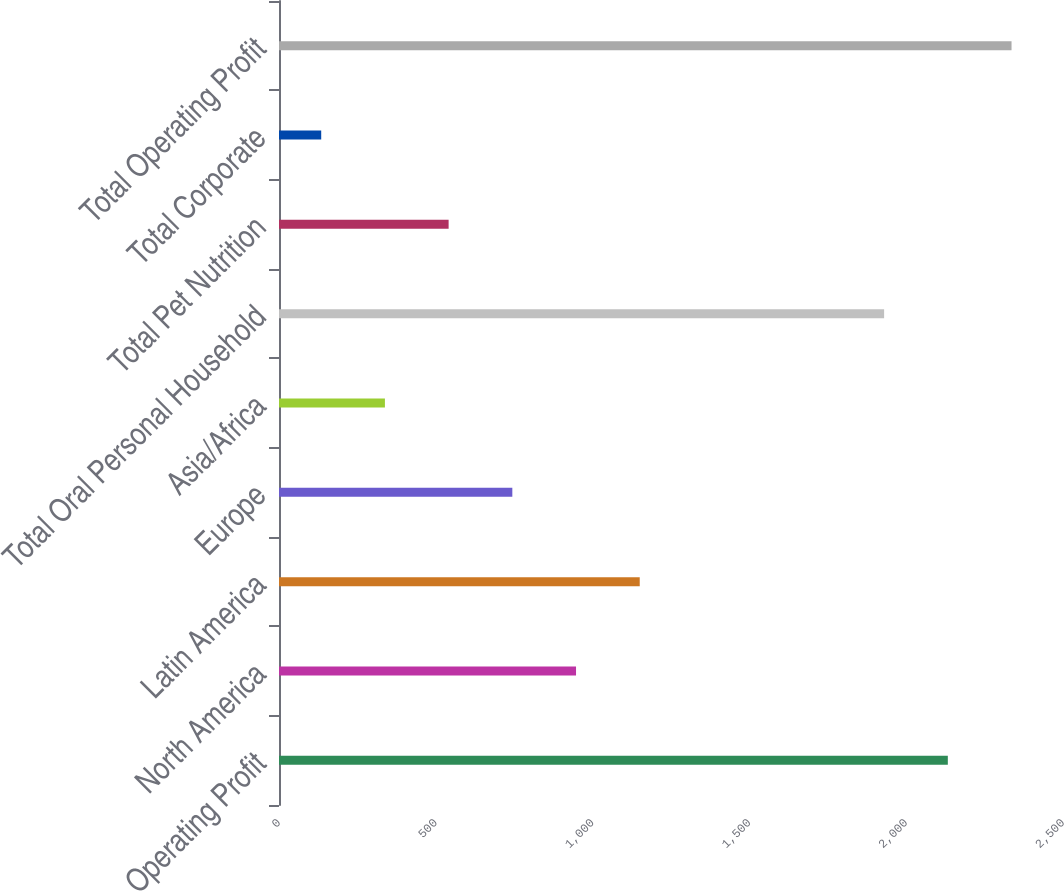Convert chart. <chart><loc_0><loc_0><loc_500><loc_500><bar_chart><fcel>Operating Profit<fcel>North America<fcel>Latin America<fcel>Europe<fcel>Asia/Africa<fcel>Total Oral Personal Household<fcel>Total Pet Nutrition<fcel>Total Corporate<fcel>Total Operating Profit<nl><fcel>2132.74<fcel>947.16<fcel>1150.3<fcel>744.02<fcel>337.74<fcel>1929.6<fcel>540.88<fcel>134.6<fcel>2335.88<nl></chart> 